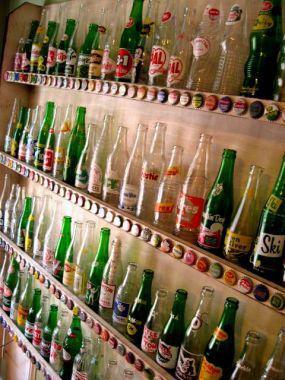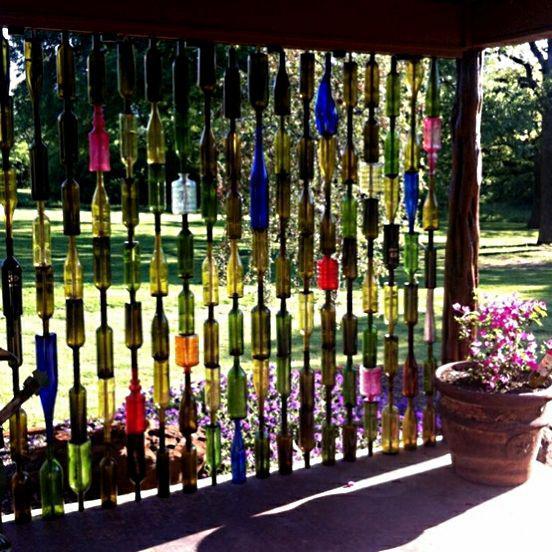The first image is the image on the left, the second image is the image on the right. For the images displayed, is the sentence "There is a wall of at least four shelves full of glass bottles." factually correct? Answer yes or no. Yes. The first image is the image on the left, the second image is the image on the right. Examine the images to the left and right. Is the description "Dozens of bottles sit on a wall shelf in one of the images." accurate? Answer yes or no. Yes. 